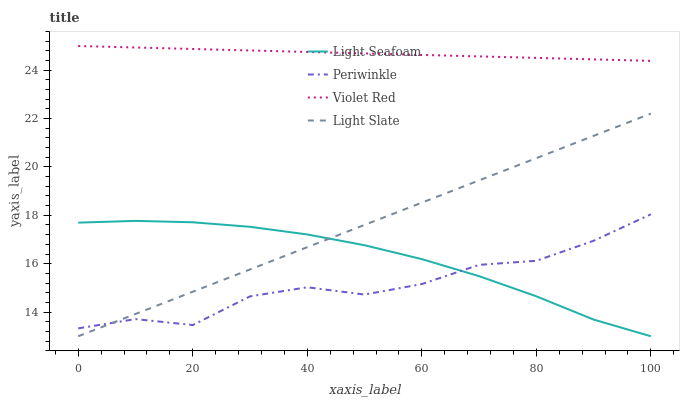Does Periwinkle have the minimum area under the curve?
Answer yes or no. Yes. Does Violet Red have the maximum area under the curve?
Answer yes or no. Yes. Does Light Seafoam have the minimum area under the curve?
Answer yes or no. No. Does Light Seafoam have the maximum area under the curve?
Answer yes or no. No. Is Light Slate the smoothest?
Answer yes or no. Yes. Is Periwinkle the roughest?
Answer yes or no. Yes. Is Violet Red the smoothest?
Answer yes or no. No. Is Violet Red the roughest?
Answer yes or no. No. Does Violet Red have the lowest value?
Answer yes or no. No. Does Violet Red have the highest value?
Answer yes or no. Yes. Does Light Seafoam have the highest value?
Answer yes or no. No. Is Periwinkle less than Violet Red?
Answer yes or no. Yes. Is Violet Red greater than Light Slate?
Answer yes or no. Yes. Does Periwinkle intersect Light Seafoam?
Answer yes or no. Yes. Is Periwinkle less than Light Seafoam?
Answer yes or no. No. Is Periwinkle greater than Light Seafoam?
Answer yes or no. No. Does Periwinkle intersect Violet Red?
Answer yes or no. No. 